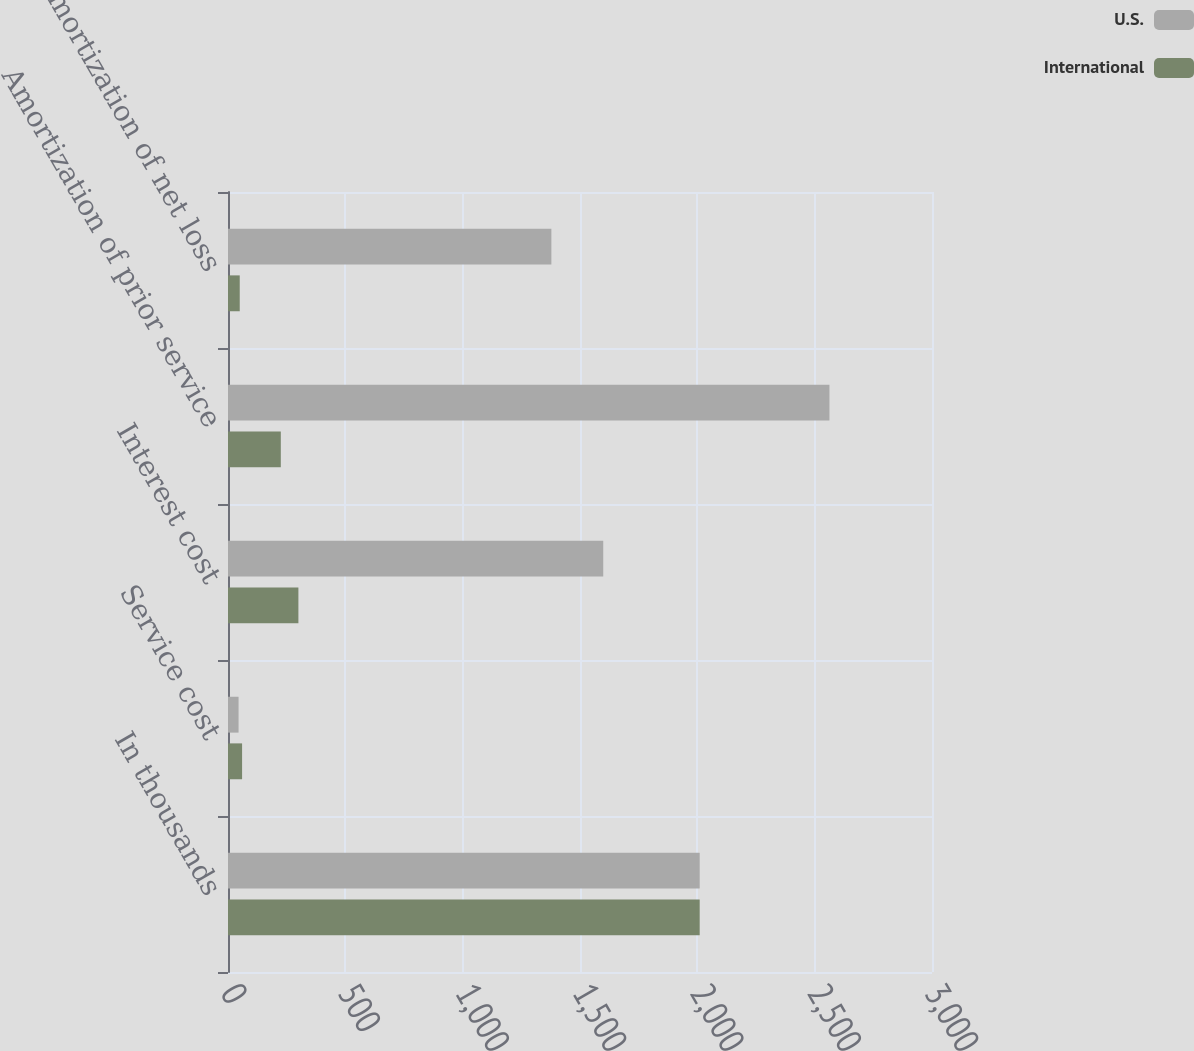<chart> <loc_0><loc_0><loc_500><loc_500><stacked_bar_chart><ecel><fcel>In thousands<fcel>Service cost<fcel>Interest cost<fcel>Amortization of prior service<fcel>Amortization of net loss<nl><fcel>U.S.<fcel>2010<fcel>45<fcel>1599<fcel>2563<fcel>1378<nl><fcel>International<fcel>2010<fcel>60<fcel>300<fcel>225<fcel>50<nl></chart> 